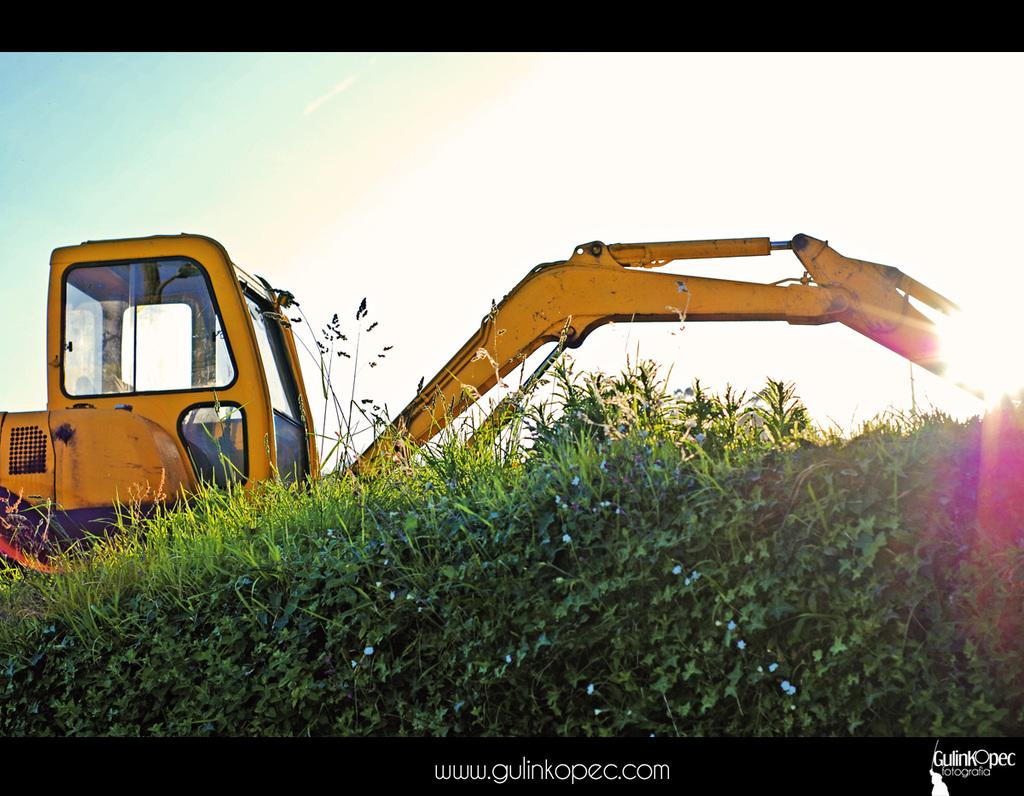What type of living organisms can be seen in the image? Plants can be seen in the image. What is located in the middle of the image? There is an excavator in the middle of the image. What can be found at the bottom of the image? There is text at the bottom of the image. What is visible at the top of the image? The sky is visible at the top of the image. What type of faucet is visible in the image? There is no faucet present in the image. Can you hear any noise coming from the excavator in the image? The image is silent, so we cannot hear any noise coming from the excavator. 